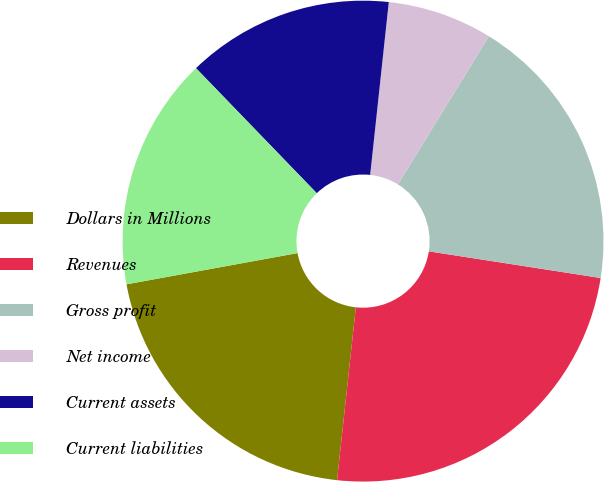<chart> <loc_0><loc_0><loc_500><loc_500><pie_chart><fcel>Dollars in Millions<fcel>Revenues<fcel>Gross profit<fcel>Net income<fcel>Current assets<fcel>Current liabilities<nl><fcel>20.4%<fcel>24.27%<fcel>18.68%<fcel>7.06%<fcel>13.93%<fcel>15.65%<nl></chart> 